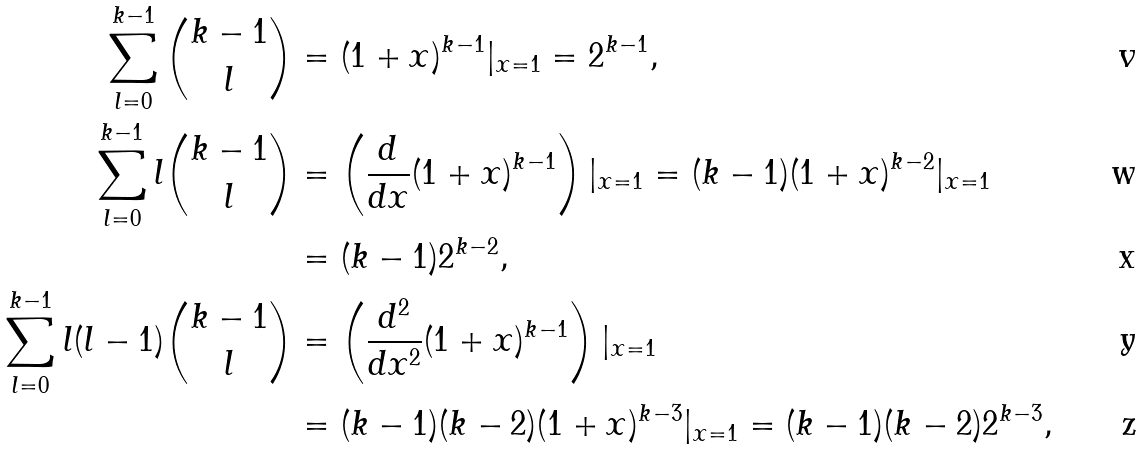Convert formula to latex. <formula><loc_0><loc_0><loc_500><loc_500>\sum _ { l = 0 } ^ { k - 1 } { \binom { k - 1 } { l } } & = ( 1 + x ) ^ { k - 1 } | _ { x = 1 } = 2 ^ { k - 1 } , \\ \sum _ { l = 0 } ^ { k - 1 } { l \binom { k - 1 } { l } } & = \left ( \frac { d } { d x } ( 1 + x ) ^ { k - 1 } \right ) | _ { x = 1 } = ( k - 1 ) ( 1 + x ) ^ { k - 2 } | _ { x = 1 } \\ & = ( k - 1 ) 2 ^ { k - 2 } , \\ \sum _ { l = 0 } ^ { k - 1 } { l ( l - 1 ) \binom { k - 1 } { l } } & = \left ( \frac { d ^ { 2 } } { d x ^ { 2 } } ( 1 + x ) ^ { k - 1 } \right ) | _ { x = 1 } \\ & = ( k - 1 ) ( k - 2 ) ( 1 + x ) ^ { k - 3 } | _ { x = 1 } = ( k - 1 ) ( k - 2 ) 2 ^ { k - 3 } ,</formula> 